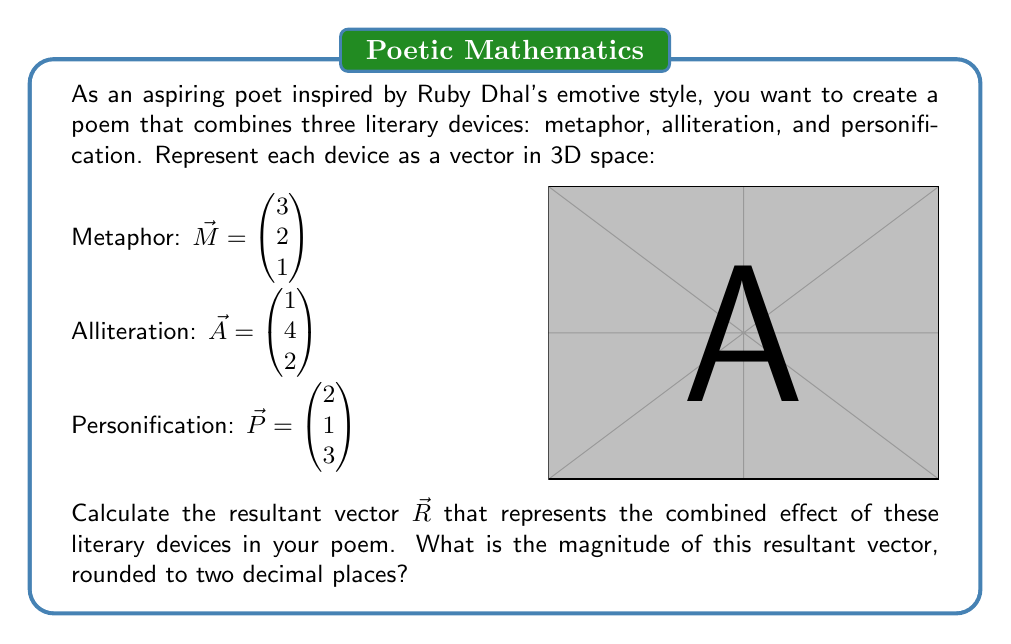Show me your answer to this math problem. To solve this problem, we'll follow these steps:

1) First, we need to add the three vectors to get the resultant vector $\vec{R}$:

   $\vec{R} = \vec{M} + \vec{A} + \vec{P}$

   $\vec{R} = \begin{pmatrix} 3 \\ 2 \\ 1 \end{pmatrix} + \begin{pmatrix} 1 \\ 4 \\ 2 \end{pmatrix} + \begin{pmatrix} 2 \\ 1 \\ 3 \end{pmatrix}$

   $\vec{R} = \begin{pmatrix} 3+1+2 \\ 2+4+1 \\ 1+2+3 \end{pmatrix} = \begin{pmatrix} 6 \\ 7 \\ 6 \end{pmatrix}$

2) Now that we have the resultant vector, we need to calculate its magnitude. The magnitude of a 3D vector $\vec{v} = (x, y, z)$ is given by the formula:

   $\|\vec{v}\| = \sqrt{x^2 + y^2 + z^2}$

3) Substituting the components of our resultant vector:

   $\|\vec{R}\| = \sqrt{6^2 + 7^2 + 6^2}$

4) Simplify:
   
   $\|\vec{R}\| = \sqrt{36 + 49 + 36} = \sqrt{121}$

5) Calculate the square root:

   $\|\vec{R}\| = 11$

6) The question asks for the result rounded to two decimal places. Since 11 is already a whole number, it remains 11.00 when rounded to two decimal places.
Answer: 11.00 